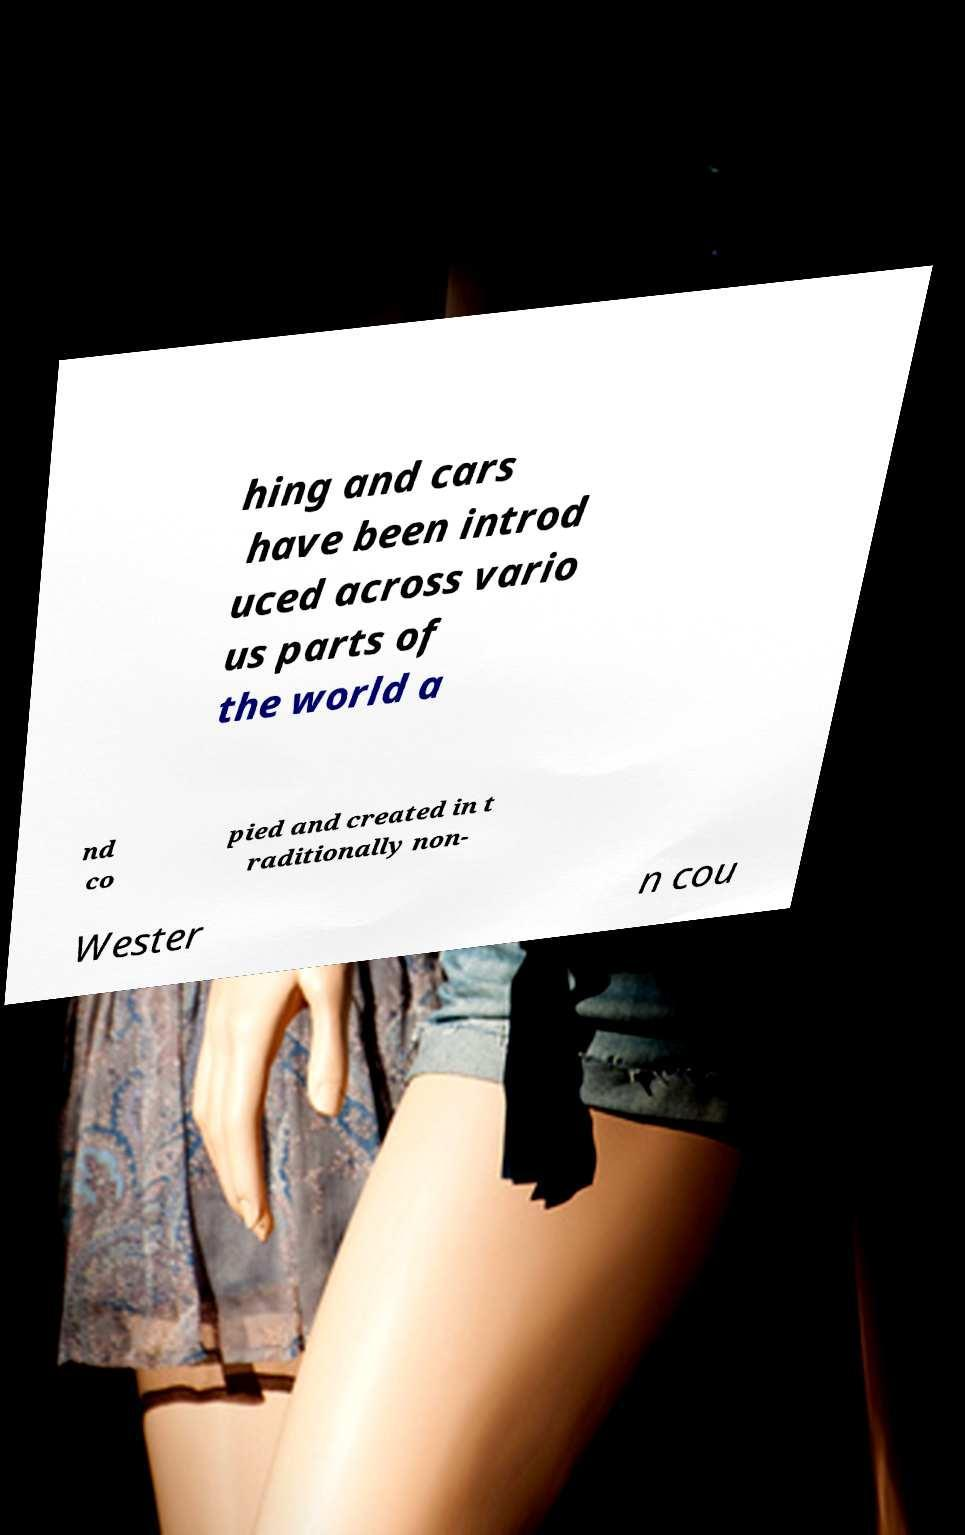Could you extract and type out the text from this image? hing and cars have been introd uced across vario us parts of the world a nd co pied and created in t raditionally non- Wester n cou 